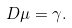Convert formula to latex. <formula><loc_0><loc_0><loc_500><loc_500>D \mu = \gamma .</formula> 